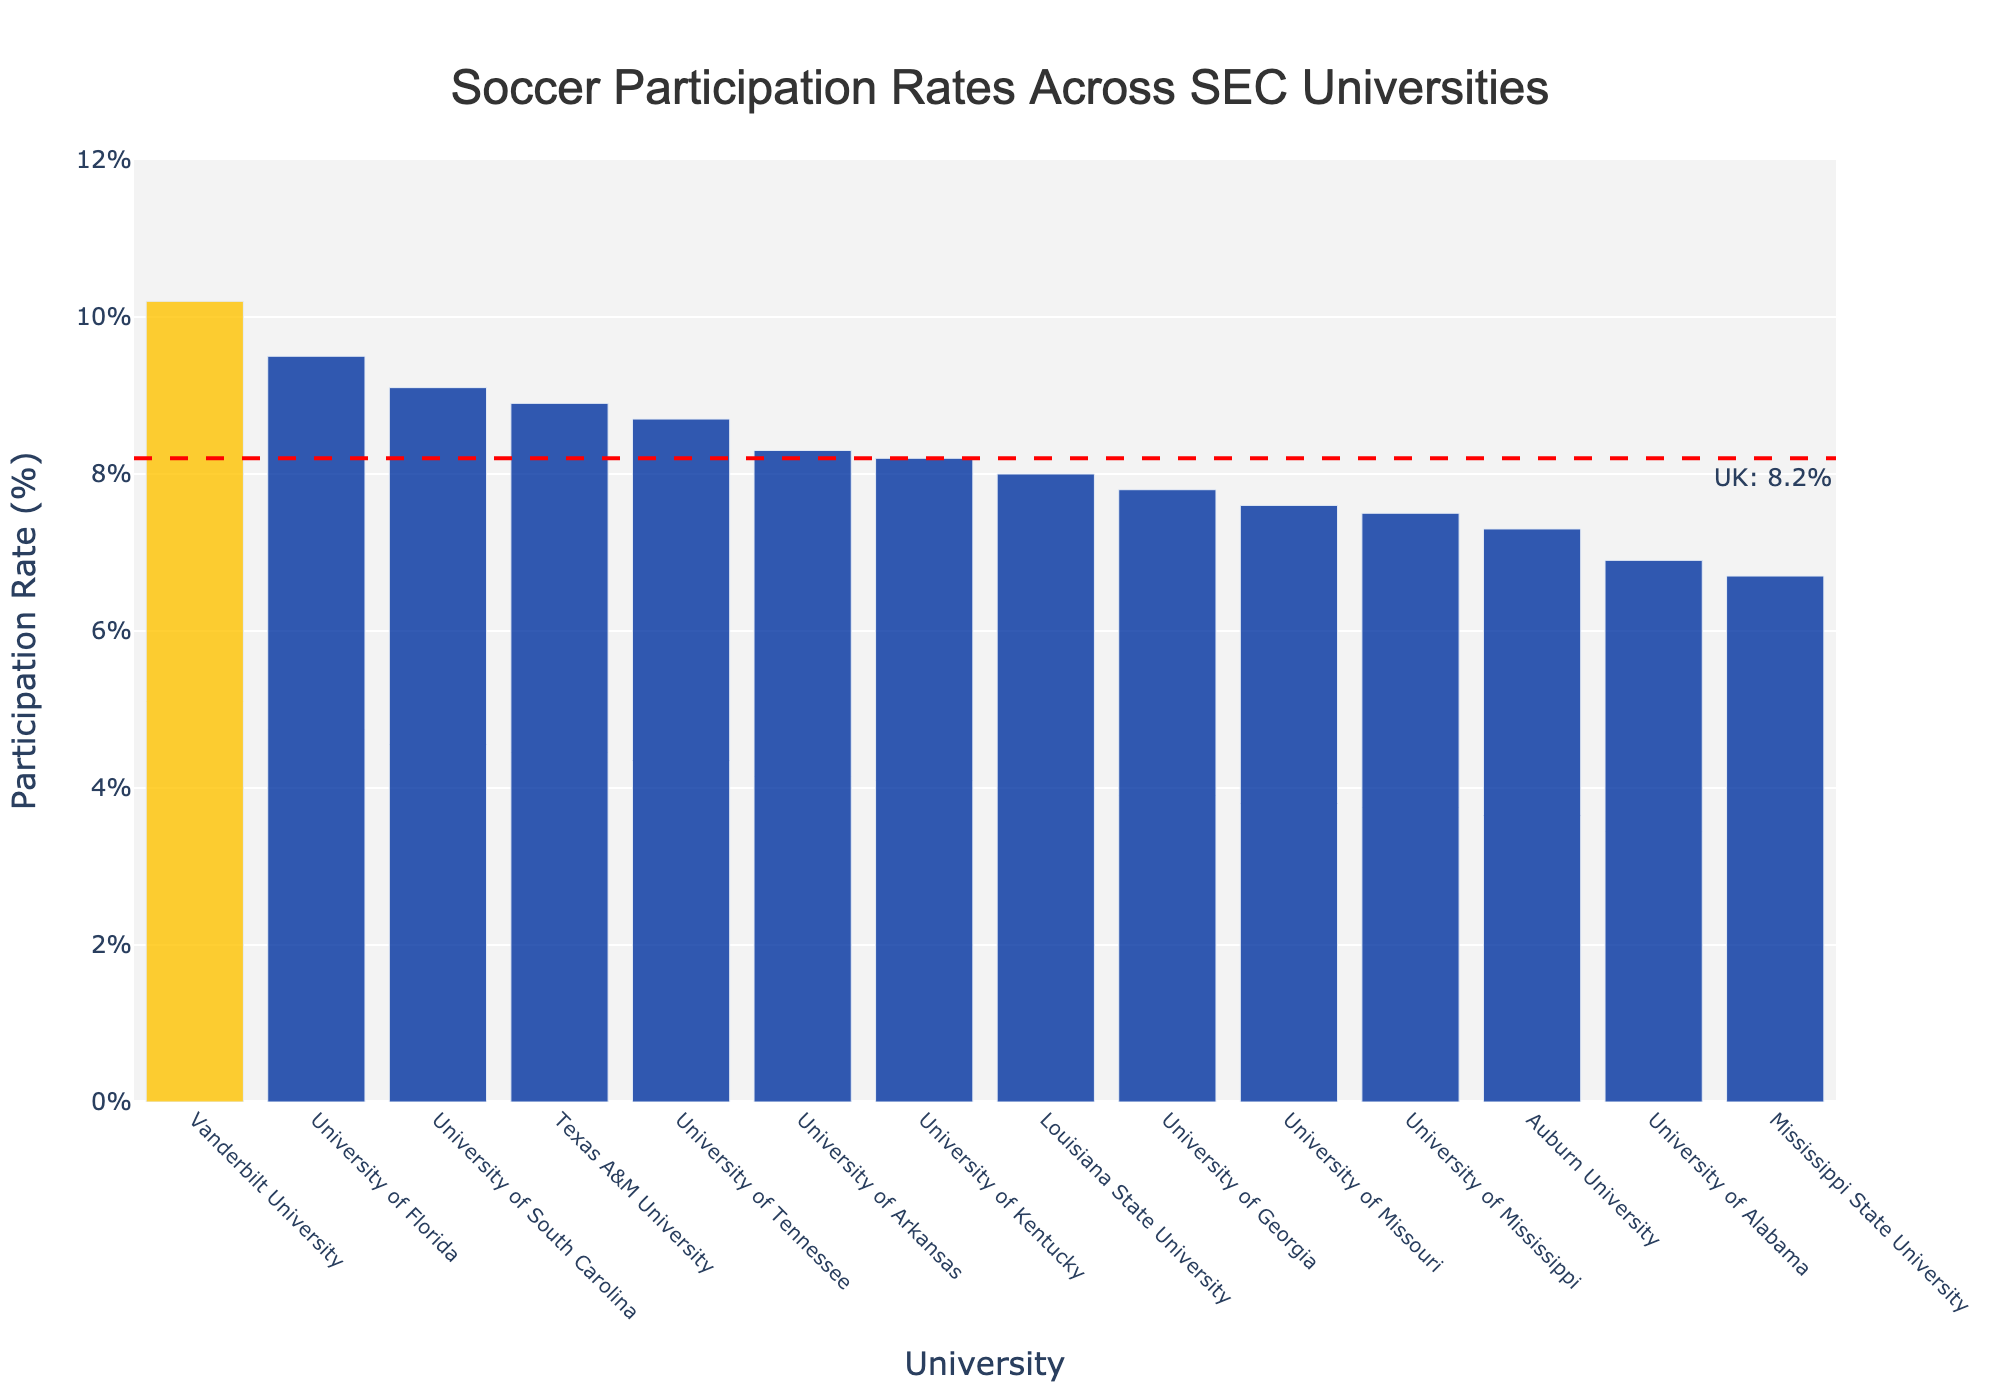Which university has the highest soccer participation rate? To find the answer, look for the tallest bar in the chart. Vanderbilt University has the tallest bar.
Answer: Vanderbilt University What is the difference in soccer participation rates between the University of Kentucky and the University of Alabama? The University of Kentucky has a participation rate of 8.2%, while the University of Alabama has a rate of 6.9%. The difference is 8.2% - 6.9%.
Answer: 1.3% Which universities have a higher soccer participation rate than the University of Kentucky? Identify the bars higher than the University of Kentucky's bar (8.2%). These universities are University of Florida, University of Tennessee, Vanderbilt University, University of South Carolina, and Texas A&M University.
Answer: University of Florida, University of Tennessee, Vanderbilt University, University of South Carolina, Texas A&M University Which university has the lowest soccer participation rate? Look for the shortest bar in the chart. Mississippi State University has the shortest bar.
Answer: Mississippi State University Is the soccer participation rate for the University of Georgia greater than that for the University of Tennessee? Compare the heights of the bars for University of Georgia (7.8%) and University of Tennessee (8.7%). The University of Tennessee has a taller bar.
Answer: No How many universities have a soccer participation rate below 8%? Count the bars that have a height corresponding to a participation rate below 8% (University of Georgia, University of Alabama, Auburn University, University of Mississippi, Mississippi State University, University of Missouri).
Answer: 6 What is the average soccer participation rate across all SEC universities? Add up all the participation rates and divide by the number of universities: (8.2 + 9.5 + 7.8 + 6.9 + 7.3 + 8.0 + 8.7 + 9.1 + 10.2 + 7.5 + 6.7 + 8.9 + 7.6 + 8.3) / 14
Answer: 8.13% What is the median soccer participation rate across all SEC universities? Arrange the participation rates in ascending order and find the middle value(s). The sorted rates are 6.7, 6.9, 7.3, 7.5, 7.6, 7.8, 8.0, 8.2, 8.3, 8.7, 8.9, 9.1, 9.5, 10.2. The median is the average of the 7th and 8th values: (8.0 + 8.2) / 2.
Answer: 8.1% Is the soccer participation rate of the University of Kentucky above or below the average rate across SEC universities? The average participation rate is 8.13%. The University of Kentucky's rate is 8.2%, so it is above average.
Answer: Above How many universities have a soccer participation rate between 7% and 9%? Count the number of universities that have bars with heights representing participation rates between 7% and 9% (University of Kentucky, University of Georgia, University of Alabama, Auburn University, Louisiana State University, University of Tennessee, University of Mississippi, University of Missouri, University of Arkansas).
Answer: 9 